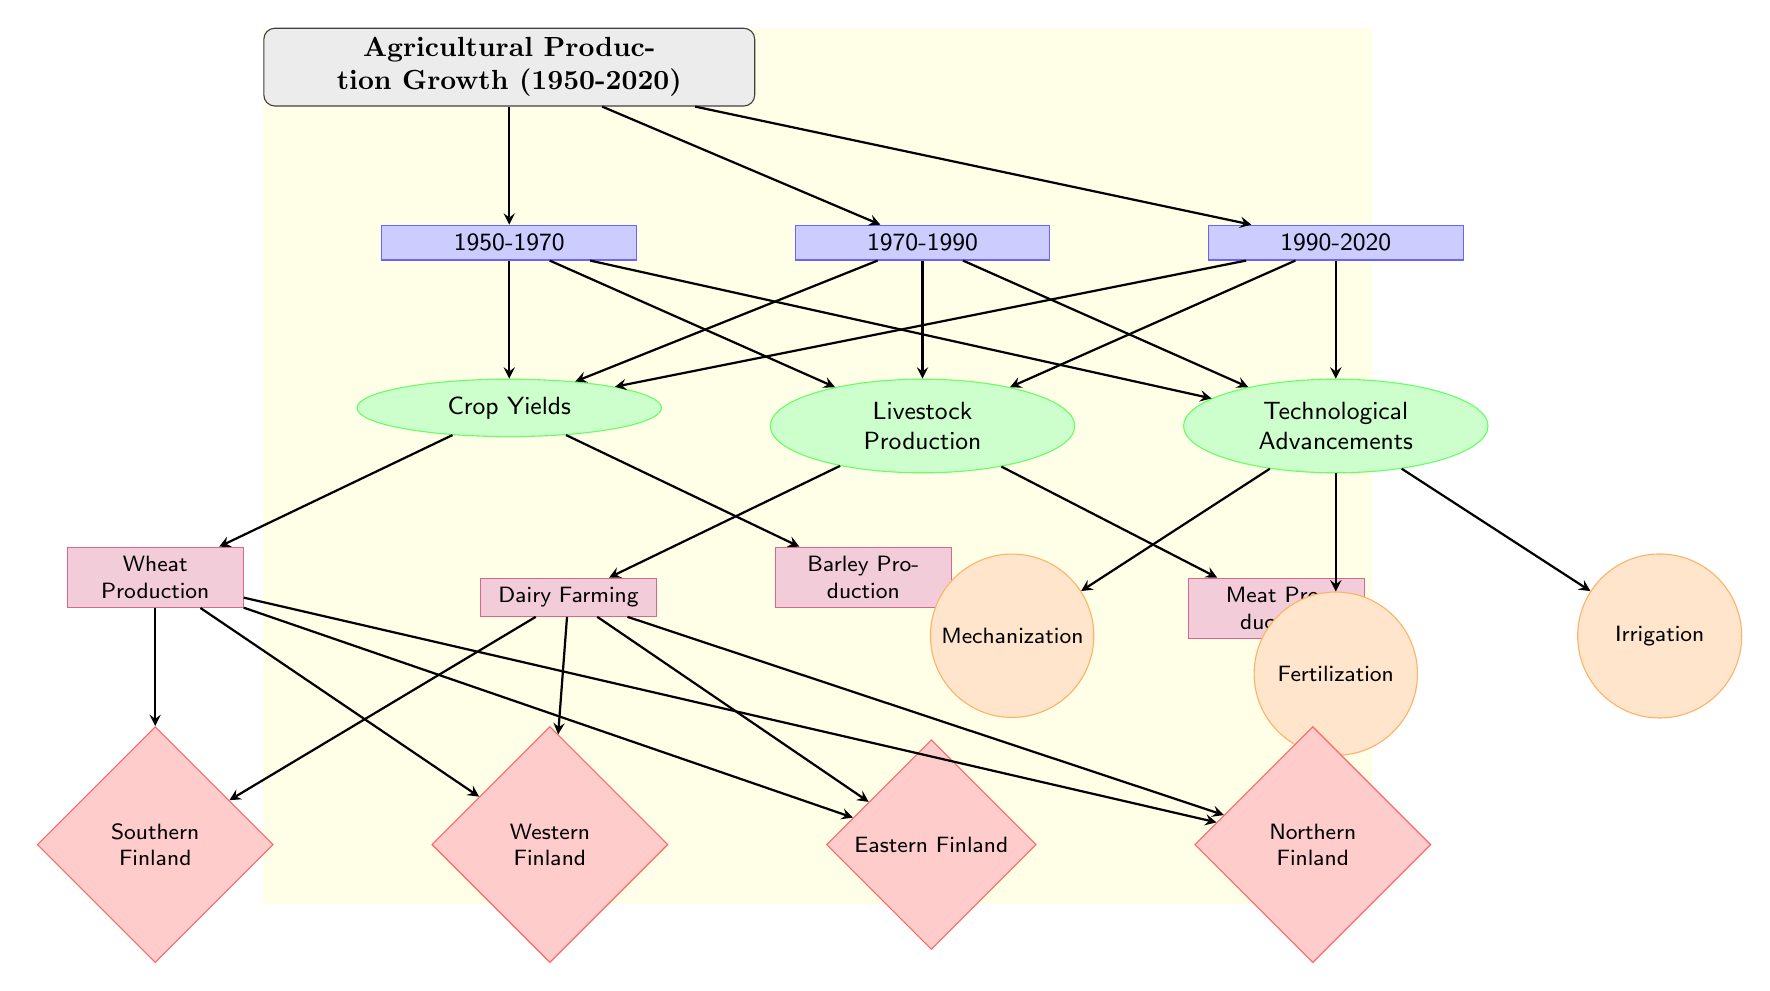What are the three main categories of agricultural production growth in the diagram? The diagram lists three main categories under the periods 1950-1970, 1970-1990, and 1990-2020. These are Crop Yields, Livestock Production, and Technological Advancements.
Answer: Crop Yields, Livestock Production, Technological Advancements Which region is directly connected to Wheat Production? Wheat Production is connected to four regions according to the diagram: Southern Finland, Western Finland, Eastern Finland, and Northern Finland. The question specifically asks for a region directly connected to Wheat Production, which can be any of these four.
Answer: Southern Finland (or any of the four regions) In which period was Livestock Production specifically categorized? The diagram illustrates that Livestock Production falls within the period labeled 1970-1990.
Answer: 1970-1990 How many factors are listed under Technological Advancements? The diagram shows a total of three factors listed under Technological Advancements, which are Mechanization, Fertilization, and Irrigation.
Answer: Three Which category is associated with Dairy Farming? Dairy Farming is associated with the category of Livestock Production, as indicated in the diagram.
Answer: Livestock Production How does Crop Yields affect the regions as per the diagram? Crop Yields has a direct connection to the regions listed below Wheat Production and Barley Production, showing its influence across those regions. As the factors of crop yields improve, the growth in the specific regions can be inferred to impact agricultural production overall.
Answer: Directly affects Southern, Western, Eastern, Northern Finland Which technological factor is not linked to both Crop Yields and Livestock Production? The diagram shows that Technological Advancements (which comprises Mechanization, Fertilization, and Irrigation) mainly influences Crop Yields and Livestock Production only indirectly, indicating farming practices; however, among the listed factors, all link to agricultural production but through indirect connections. Mechanization shows a more specific influence noted comparatively through the growth.
Answer: None (All linked indirectly) What type of arrows are used to connect nodes in this diagram? The diagram uses arrows that are styled as directed edges. These show the relationship and flow from one node to another, indicating a specific direction in the associations they represent.
Answer: Directed edges Which period and category might indicate significant change in livestock practices based on the diagram? The period and category indicated by the diagonal connection focusing on Livestock Production is 1970-1990. This period distinctly focuses on dairy and meat-related growth, suggesting a significant shift.
Answer: 1970-1990, Livestock Production 